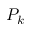<formula> <loc_0><loc_0><loc_500><loc_500>P _ { k }</formula> 